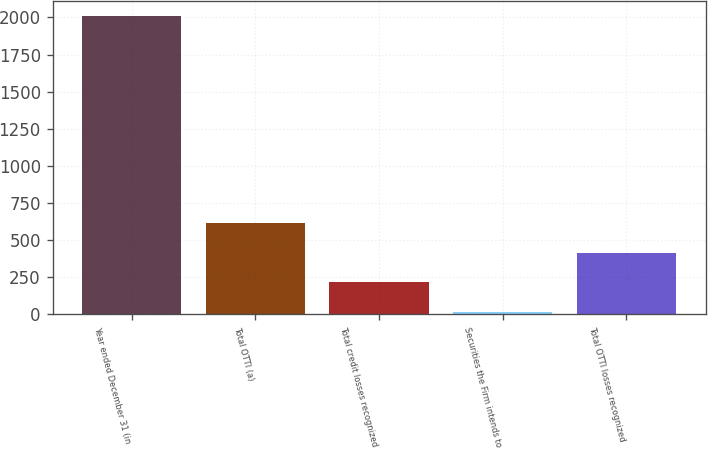<chart> <loc_0><loc_0><loc_500><loc_500><bar_chart><fcel>Year ended December 31 (in<fcel>Total OTTI (a)<fcel>Total credit losses recognized<fcel>Securities the Firm intends to<fcel>Total OTTI losses recognized<nl><fcel>2012<fcel>614.1<fcel>214.7<fcel>15<fcel>414.4<nl></chart> 